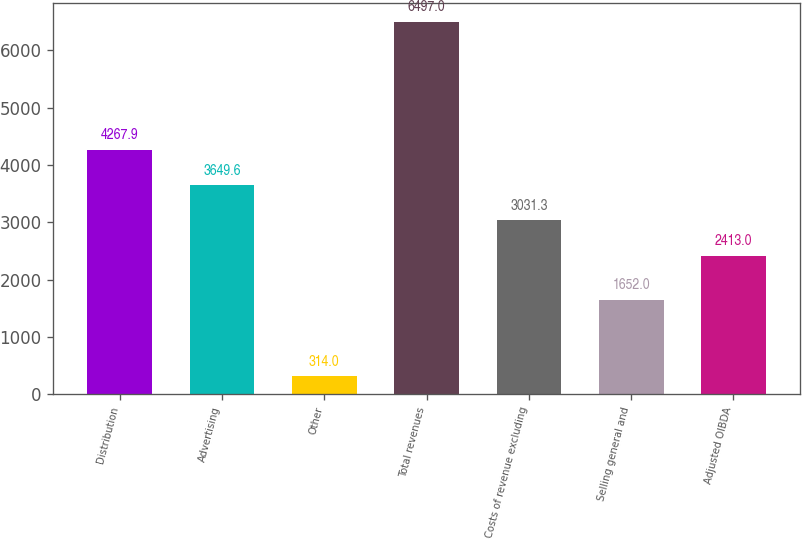Convert chart. <chart><loc_0><loc_0><loc_500><loc_500><bar_chart><fcel>Distribution<fcel>Advertising<fcel>Other<fcel>Total revenues<fcel>Costs of revenue excluding<fcel>Selling general and<fcel>Adjusted OIBDA<nl><fcel>4267.9<fcel>3649.6<fcel>314<fcel>6497<fcel>3031.3<fcel>1652<fcel>2413<nl></chart> 